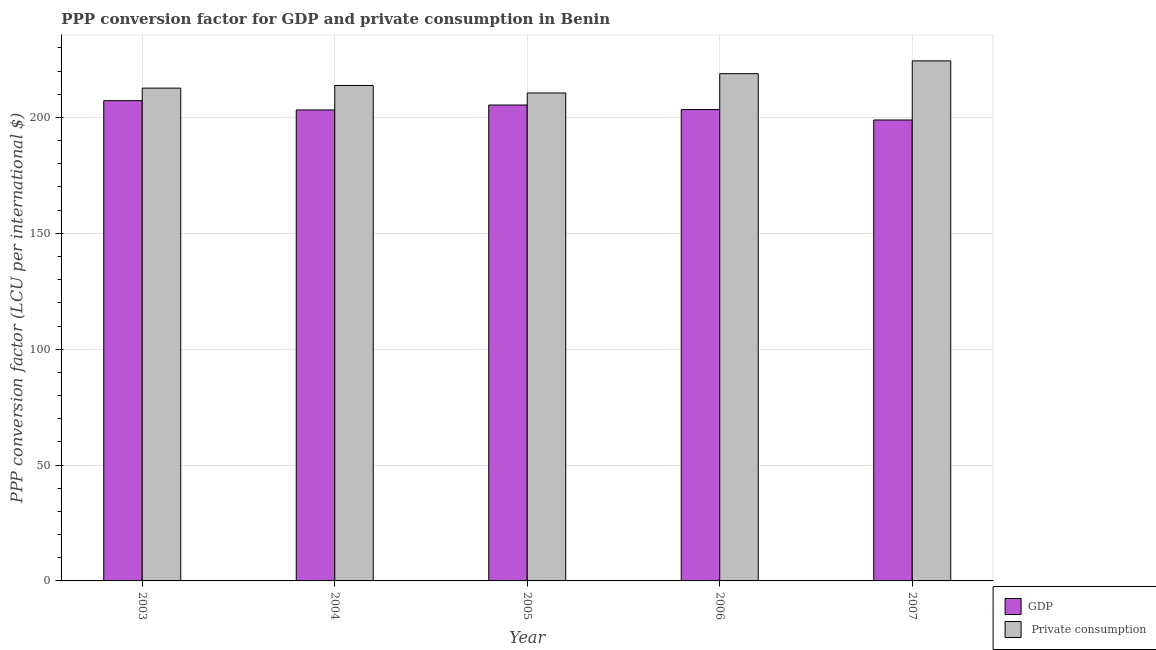How many groups of bars are there?
Your answer should be very brief. 5. Are the number of bars on each tick of the X-axis equal?
Offer a terse response. Yes. How many bars are there on the 1st tick from the left?
Your answer should be very brief. 2. What is the ppp conversion factor for gdp in 2003?
Ensure brevity in your answer.  207.24. Across all years, what is the maximum ppp conversion factor for gdp?
Provide a short and direct response. 207.24. Across all years, what is the minimum ppp conversion factor for gdp?
Provide a succinct answer. 198.91. In which year was the ppp conversion factor for private consumption maximum?
Your response must be concise. 2007. In which year was the ppp conversion factor for gdp minimum?
Make the answer very short. 2007. What is the total ppp conversion factor for gdp in the graph?
Offer a terse response. 1018.17. What is the difference between the ppp conversion factor for private consumption in 2004 and that in 2005?
Keep it short and to the point. 3.23. What is the difference between the ppp conversion factor for private consumption in 2003 and the ppp conversion factor for gdp in 2006?
Make the answer very short. -6.25. What is the average ppp conversion factor for private consumption per year?
Make the answer very short. 216.07. In the year 2006, what is the difference between the ppp conversion factor for private consumption and ppp conversion factor for gdp?
Ensure brevity in your answer.  0. In how many years, is the ppp conversion factor for gdp greater than 80 LCU?
Give a very brief answer. 5. What is the ratio of the ppp conversion factor for private consumption in 2006 to that in 2007?
Offer a very short reply. 0.98. Is the difference between the ppp conversion factor for gdp in 2005 and 2006 greater than the difference between the ppp conversion factor for private consumption in 2005 and 2006?
Give a very brief answer. No. What is the difference between the highest and the second highest ppp conversion factor for private consumption?
Your answer should be compact. 5.52. What is the difference between the highest and the lowest ppp conversion factor for private consumption?
Your answer should be compact. 13.85. In how many years, is the ppp conversion factor for private consumption greater than the average ppp conversion factor for private consumption taken over all years?
Your answer should be very brief. 2. What does the 2nd bar from the left in 2006 represents?
Offer a terse response.  Private consumption. What does the 2nd bar from the right in 2004 represents?
Your answer should be very brief. GDP. Are the values on the major ticks of Y-axis written in scientific E-notation?
Provide a succinct answer. No. Does the graph contain any zero values?
Provide a succinct answer. No. Where does the legend appear in the graph?
Provide a succinct answer. Bottom right. What is the title of the graph?
Your answer should be compact. PPP conversion factor for GDP and private consumption in Benin. Does "Secondary school" appear as one of the legend labels in the graph?
Keep it short and to the point. No. What is the label or title of the X-axis?
Your response must be concise. Year. What is the label or title of the Y-axis?
Your answer should be very brief. PPP conversion factor (LCU per international $). What is the PPP conversion factor (LCU per international $) of GDP in 2003?
Keep it short and to the point. 207.24. What is the PPP conversion factor (LCU per international $) of  Private consumption in 2003?
Your answer should be compact. 212.65. What is the PPP conversion factor (LCU per international $) in GDP in 2004?
Your answer should be compact. 203.24. What is the PPP conversion factor (LCU per international $) in  Private consumption in 2004?
Keep it short and to the point. 213.8. What is the PPP conversion factor (LCU per international $) of GDP in 2005?
Your response must be concise. 205.36. What is the PPP conversion factor (LCU per international $) of  Private consumption in 2005?
Give a very brief answer. 210.57. What is the PPP conversion factor (LCU per international $) of GDP in 2006?
Give a very brief answer. 203.41. What is the PPP conversion factor (LCU per international $) of  Private consumption in 2006?
Offer a terse response. 218.9. What is the PPP conversion factor (LCU per international $) of GDP in 2007?
Keep it short and to the point. 198.91. What is the PPP conversion factor (LCU per international $) in  Private consumption in 2007?
Provide a succinct answer. 224.42. Across all years, what is the maximum PPP conversion factor (LCU per international $) in GDP?
Make the answer very short. 207.24. Across all years, what is the maximum PPP conversion factor (LCU per international $) of  Private consumption?
Give a very brief answer. 224.42. Across all years, what is the minimum PPP conversion factor (LCU per international $) in GDP?
Provide a succinct answer. 198.91. Across all years, what is the minimum PPP conversion factor (LCU per international $) of  Private consumption?
Provide a short and direct response. 210.57. What is the total PPP conversion factor (LCU per international $) in GDP in the graph?
Keep it short and to the point. 1018.17. What is the total PPP conversion factor (LCU per international $) of  Private consumption in the graph?
Your answer should be compact. 1080.33. What is the difference between the PPP conversion factor (LCU per international $) of GDP in 2003 and that in 2004?
Provide a short and direct response. 3.99. What is the difference between the PPP conversion factor (LCU per international $) of  Private consumption in 2003 and that in 2004?
Offer a very short reply. -1.15. What is the difference between the PPP conversion factor (LCU per international $) of GDP in 2003 and that in 2005?
Keep it short and to the point. 1.87. What is the difference between the PPP conversion factor (LCU per international $) in  Private consumption in 2003 and that in 2005?
Offer a terse response. 2.09. What is the difference between the PPP conversion factor (LCU per international $) of GDP in 2003 and that in 2006?
Offer a very short reply. 3.83. What is the difference between the PPP conversion factor (LCU per international $) in  Private consumption in 2003 and that in 2006?
Provide a succinct answer. -6.25. What is the difference between the PPP conversion factor (LCU per international $) in GDP in 2003 and that in 2007?
Keep it short and to the point. 8.33. What is the difference between the PPP conversion factor (LCU per international $) of  Private consumption in 2003 and that in 2007?
Provide a short and direct response. -11.76. What is the difference between the PPP conversion factor (LCU per international $) in GDP in 2004 and that in 2005?
Provide a short and direct response. -2.12. What is the difference between the PPP conversion factor (LCU per international $) of  Private consumption in 2004 and that in 2005?
Make the answer very short. 3.23. What is the difference between the PPP conversion factor (LCU per international $) of GDP in 2004 and that in 2006?
Offer a very short reply. -0.17. What is the difference between the PPP conversion factor (LCU per international $) in  Private consumption in 2004 and that in 2006?
Your answer should be very brief. -5.1. What is the difference between the PPP conversion factor (LCU per international $) of GDP in 2004 and that in 2007?
Your response must be concise. 4.33. What is the difference between the PPP conversion factor (LCU per international $) in  Private consumption in 2004 and that in 2007?
Give a very brief answer. -10.62. What is the difference between the PPP conversion factor (LCU per international $) of GDP in 2005 and that in 2006?
Your answer should be very brief. 1.95. What is the difference between the PPP conversion factor (LCU per international $) of  Private consumption in 2005 and that in 2006?
Offer a terse response. -8.33. What is the difference between the PPP conversion factor (LCU per international $) of GDP in 2005 and that in 2007?
Give a very brief answer. 6.45. What is the difference between the PPP conversion factor (LCU per international $) in  Private consumption in 2005 and that in 2007?
Make the answer very short. -13.85. What is the difference between the PPP conversion factor (LCU per international $) of GDP in 2006 and that in 2007?
Provide a succinct answer. 4.5. What is the difference between the PPP conversion factor (LCU per international $) of  Private consumption in 2006 and that in 2007?
Offer a terse response. -5.52. What is the difference between the PPP conversion factor (LCU per international $) of GDP in 2003 and the PPP conversion factor (LCU per international $) of  Private consumption in 2004?
Offer a terse response. -6.56. What is the difference between the PPP conversion factor (LCU per international $) in GDP in 2003 and the PPP conversion factor (LCU per international $) in  Private consumption in 2005?
Provide a succinct answer. -3.33. What is the difference between the PPP conversion factor (LCU per international $) of GDP in 2003 and the PPP conversion factor (LCU per international $) of  Private consumption in 2006?
Provide a short and direct response. -11.66. What is the difference between the PPP conversion factor (LCU per international $) of GDP in 2003 and the PPP conversion factor (LCU per international $) of  Private consumption in 2007?
Your answer should be compact. -17.18. What is the difference between the PPP conversion factor (LCU per international $) of GDP in 2004 and the PPP conversion factor (LCU per international $) of  Private consumption in 2005?
Ensure brevity in your answer.  -7.32. What is the difference between the PPP conversion factor (LCU per international $) of GDP in 2004 and the PPP conversion factor (LCU per international $) of  Private consumption in 2006?
Provide a succinct answer. -15.65. What is the difference between the PPP conversion factor (LCU per international $) of GDP in 2004 and the PPP conversion factor (LCU per international $) of  Private consumption in 2007?
Provide a succinct answer. -21.17. What is the difference between the PPP conversion factor (LCU per international $) of GDP in 2005 and the PPP conversion factor (LCU per international $) of  Private consumption in 2006?
Provide a short and direct response. -13.53. What is the difference between the PPP conversion factor (LCU per international $) in GDP in 2005 and the PPP conversion factor (LCU per international $) in  Private consumption in 2007?
Ensure brevity in your answer.  -19.05. What is the difference between the PPP conversion factor (LCU per international $) in GDP in 2006 and the PPP conversion factor (LCU per international $) in  Private consumption in 2007?
Your response must be concise. -21.01. What is the average PPP conversion factor (LCU per international $) in GDP per year?
Keep it short and to the point. 203.63. What is the average PPP conversion factor (LCU per international $) in  Private consumption per year?
Your response must be concise. 216.07. In the year 2003, what is the difference between the PPP conversion factor (LCU per international $) of GDP and PPP conversion factor (LCU per international $) of  Private consumption?
Offer a terse response. -5.41. In the year 2004, what is the difference between the PPP conversion factor (LCU per international $) of GDP and PPP conversion factor (LCU per international $) of  Private consumption?
Your response must be concise. -10.55. In the year 2005, what is the difference between the PPP conversion factor (LCU per international $) of GDP and PPP conversion factor (LCU per international $) of  Private consumption?
Ensure brevity in your answer.  -5.2. In the year 2006, what is the difference between the PPP conversion factor (LCU per international $) in GDP and PPP conversion factor (LCU per international $) in  Private consumption?
Your answer should be compact. -15.49. In the year 2007, what is the difference between the PPP conversion factor (LCU per international $) of GDP and PPP conversion factor (LCU per international $) of  Private consumption?
Offer a terse response. -25.51. What is the ratio of the PPP conversion factor (LCU per international $) of GDP in 2003 to that in 2004?
Give a very brief answer. 1.02. What is the ratio of the PPP conversion factor (LCU per international $) in  Private consumption in 2003 to that in 2004?
Your answer should be compact. 0.99. What is the ratio of the PPP conversion factor (LCU per international $) of GDP in 2003 to that in 2005?
Your answer should be very brief. 1.01. What is the ratio of the PPP conversion factor (LCU per international $) in  Private consumption in 2003 to that in 2005?
Offer a terse response. 1.01. What is the ratio of the PPP conversion factor (LCU per international $) of GDP in 2003 to that in 2006?
Ensure brevity in your answer.  1.02. What is the ratio of the PPP conversion factor (LCU per international $) in  Private consumption in 2003 to that in 2006?
Ensure brevity in your answer.  0.97. What is the ratio of the PPP conversion factor (LCU per international $) of GDP in 2003 to that in 2007?
Your answer should be compact. 1.04. What is the ratio of the PPP conversion factor (LCU per international $) of  Private consumption in 2003 to that in 2007?
Offer a very short reply. 0.95. What is the ratio of the PPP conversion factor (LCU per international $) of GDP in 2004 to that in 2005?
Your answer should be very brief. 0.99. What is the ratio of the PPP conversion factor (LCU per international $) in  Private consumption in 2004 to that in 2005?
Provide a succinct answer. 1.02. What is the ratio of the PPP conversion factor (LCU per international $) in GDP in 2004 to that in 2006?
Provide a short and direct response. 1. What is the ratio of the PPP conversion factor (LCU per international $) in  Private consumption in 2004 to that in 2006?
Offer a very short reply. 0.98. What is the ratio of the PPP conversion factor (LCU per international $) of GDP in 2004 to that in 2007?
Provide a succinct answer. 1.02. What is the ratio of the PPP conversion factor (LCU per international $) in  Private consumption in 2004 to that in 2007?
Offer a terse response. 0.95. What is the ratio of the PPP conversion factor (LCU per international $) of GDP in 2005 to that in 2006?
Offer a very short reply. 1.01. What is the ratio of the PPP conversion factor (LCU per international $) of  Private consumption in 2005 to that in 2006?
Give a very brief answer. 0.96. What is the ratio of the PPP conversion factor (LCU per international $) of GDP in 2005 to that in 2007?
Your answer should be very brief. 1.03. What is the ratio of the PPP conversion factor (LCU per international $) of  Private consumption in 2005 to that in 2007?
Your answer should be very brief. 0.94. What is the ratio of the PPP conversion factor (LCU per international $) in GDP in 2006 to that in 2007?
Offer a very short reply. 1.02. What is the ratio of the PPP conversion factor (LCU per international $) in  Private consumption in 2006 to that in 2007?
Your answer should be very brief. 0.98. What is the difference between the highest and the second highest PPP conversion factor (LCU per international $) in GDP?
Your answer should be very brief. 1.87. What is the difference between the highest and the second highest PPP conversion factor (LCU per international $) of  Private consumption?
Give a very brief answer. 5.52. What is the difference between the highest and the lowest PPP conversion factor (LCU per international $) in GDP?
Provide a succinct answer. 8.33. What is the difference between the highest and the lowest PPP conversion factor (LCU per international $) in  Private consumption?
Offer a terse response. 13.85. 